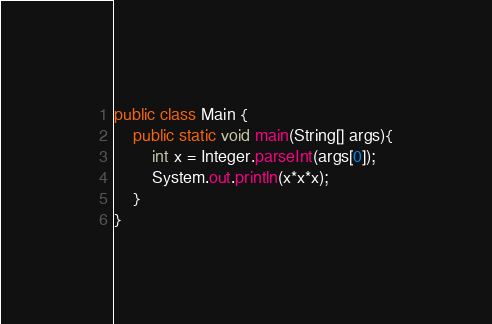<code> <loc_0><loc_0><loc_500><loc_500><_Java_>public class Main {
    public static void main(String[] args){
        int x = Integer.parseInt(args[0]);
        System.out.println(x*x*x);
    }
}
</code> 